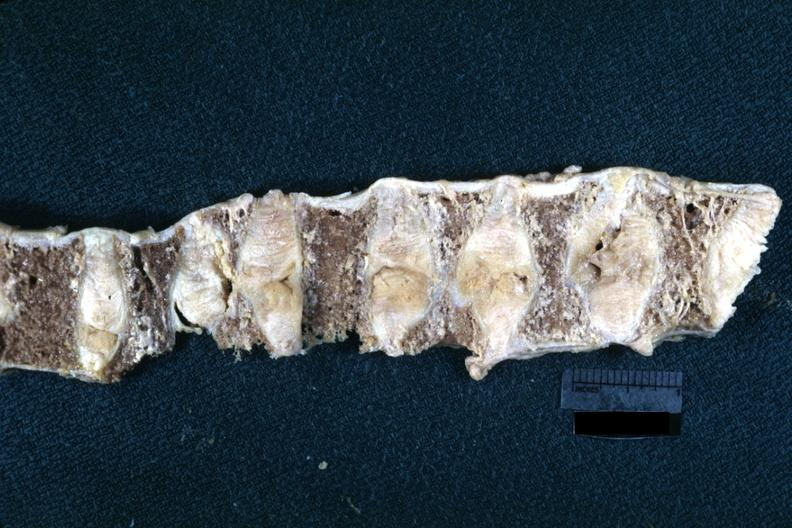what is present?
Answer the question using a single word or phrase. Joints 